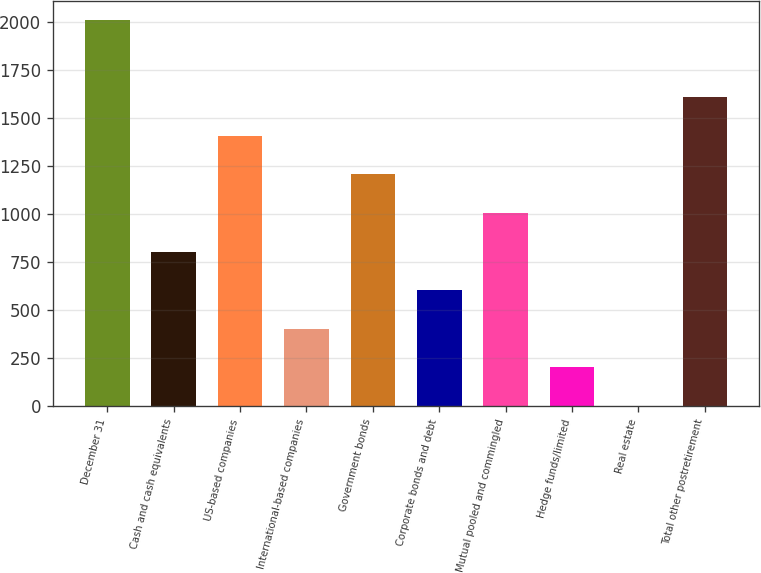Convert chart. <chart><loc_0><loc_0><loc_500><loc_500><bar_chart><fcel>December 31<fcel>Cash and cash equivalents<fcel>US-based companies<fcel>International-based companies<fcel>Government bonds<fcel>Corporate bonds and debt<fcel>Mutual pooled and commingled<fcel>Hedge funds/limited<fcel>Real estate<fcel>Total other postretirement<nl><fcel>2013<fcel>806.4<fcel>1409.7<fcel>404.2<fcel>1208.6<fcel>605.3<fcel>1007.5<fcel>203.1<fcel>2<fcel>1610.8<nl></chart> 